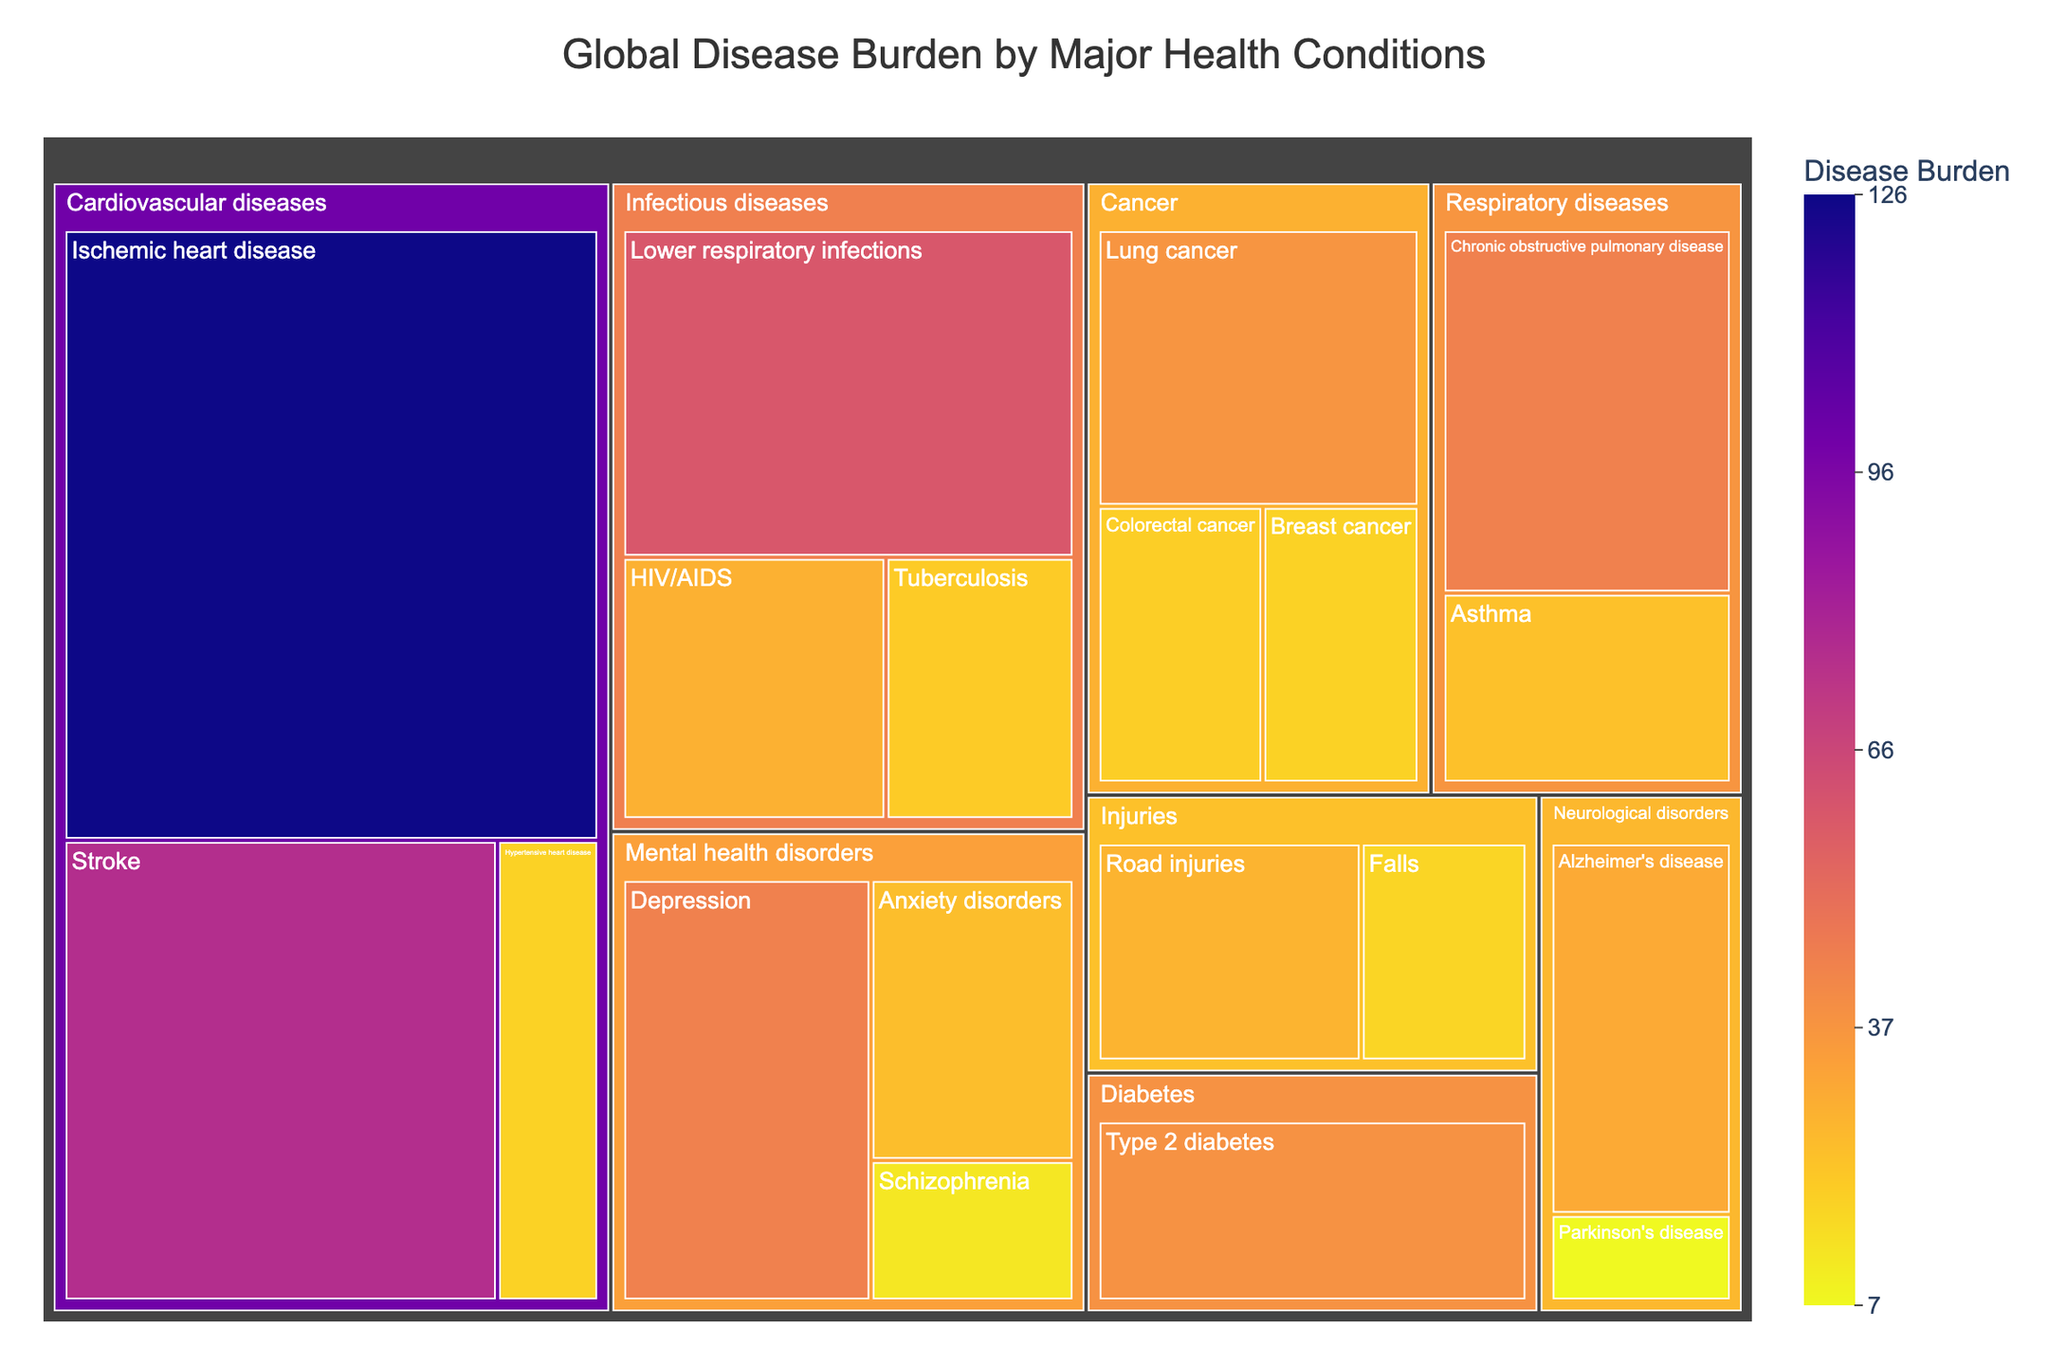What is the title of the treemap? The title is displayed prominently at the top of the treemap and provides a summary of what the visualization is about.
Answer: Global Disease Burden by Major Health Conditions How many subcategories fall under Cardiovascular diseases? By examining the visual structure, locate Cardiovascular diseases and count the number of individual boxes (subcategories) nested within it.
Answer: 3 Which health condition has the highest disease burden? Look for the largest box in the treemap, as size represents the value of the disease burden.
Answer: Ischemic heart disease Compare the disease burden of Depression and Chronic obstructive pulmonary disease (COPD). Which one is higher? Identify the boxes for both Depression and COPD, and compare their sizes/values directly.
Answer: Depression What is the combined disease burden for Neurological disorders? Locate the subcategories under Neurological disorders and sum their values: Alzheimer's disease (30) + Parkinson's disease (7).
Answer: 37 Which category has the smallest disease burden within the given data? Look for the category with the smallest total box size. Compare the sizes of the primary categories (Cardiovascular diseases, Infectious diseases, Cancer, etc.).
Answer: Injuries How does the disease burden of Type 2 diabetes compare to Road injuries? Locate both Type 2 diabetes and Road injuries in the treemap and compare their sizes/values.
Answer: Type 2 diabetes is higher What is the average disease burden across all mental health disorders? Identify the values for all mental health disorders: Depression (44), Anxiety disorders (24), Schizophrenia (12). Compute the average: (44 + 24 + 12) / 3.
Answer: 26.67 What is the total disease burden for all Cancer subcategories combined? Sum the values for Lung cancer (37), Breast cancer (18), and Colorectal cancer (19).
Answer: 74 Which subcategory within infectious diseases has the lowest burden? Examine the subcategories under Infectious diseases and identify the one with the smallest value.
Answer: Tuberculosis 